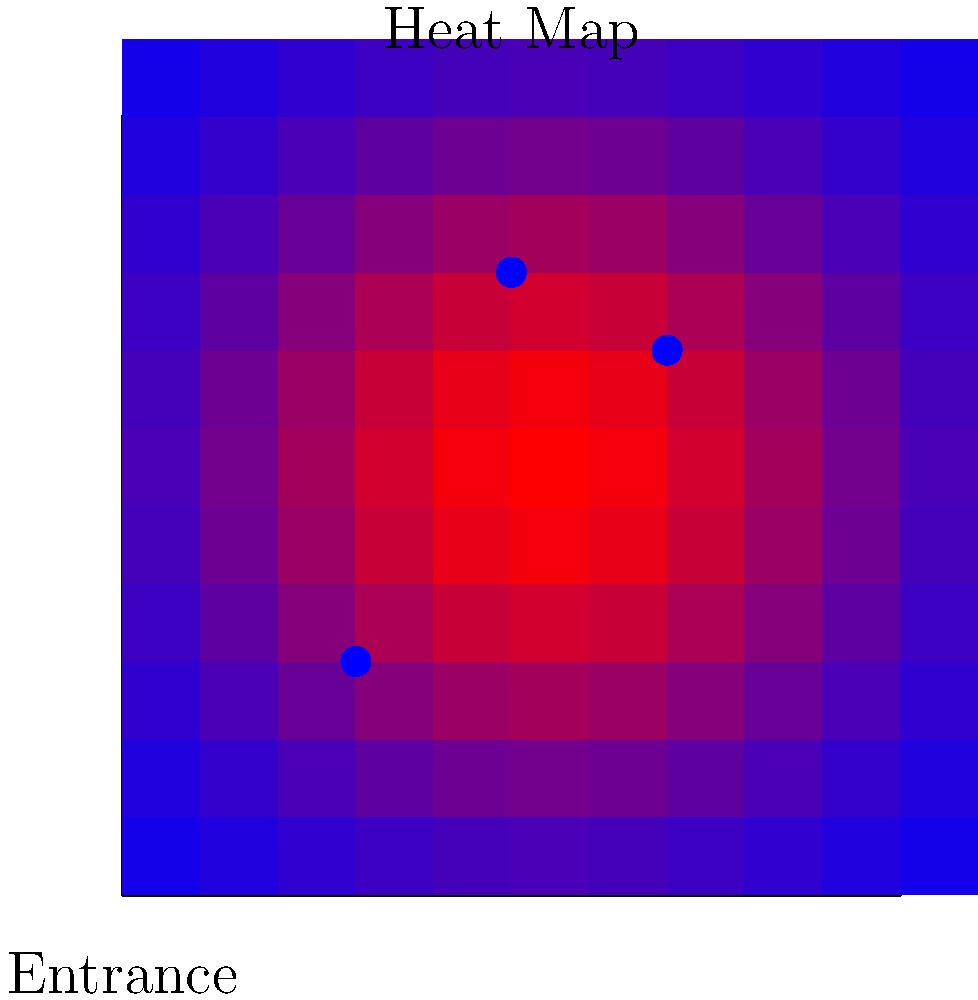Given the heat map of customer traffic in a retail space as shown in the image, where should the third virtual product display be optimally placed to maximize customer engagement? Assume the two existing displays are fixed at coordinates (3,3) and (7,7), and the new display should be placed at least 2 units away from existing displays. Express your answer as coordinates (x,y) rounded to the nearest integer. To solve this problem, we need to follow these steps:

1. Analyze the heat map:
   The red areas indicate high customer traffic, while blue areas indicate low traffic.

2. Identify the hottest area:
   The center of the store (around coordinates (5,5)) appears to be the hottest zone.

3. Consider existing display locations:
   - Display 1: (3,3)
   - Display 2: (7,7)

4. Apply the distance constraint:
   The new display must be at least 2 units away from existing displays.

5. Find potential locations:
   Areas that meet the distance constraint and are in high-traffic zones include:
   - Upper central area (around (5,8))
   - Lower right area (around (8,3))

6. Evaluate the options:
   The upper central area (5,8) appears to have higher traffic (more red) compared to (8,3).

7. Verify the distance constraint:
   Distance from (5,8) to (3,3): $$\sqrt{(5-3)^2 + (8-3)^2} \approx 5.39 > 2$$
   Distance from (5,8) to (7,7): $$\sqrt{(5-7)^2 + (8-7)^2} \approx 2.24 > 2$$

Therefore, the optimal placement for the third virtual product display is at coordinates (5,8), which maximizes customer engagement while satisfying the distance constraint.
Answer: (5,8) 